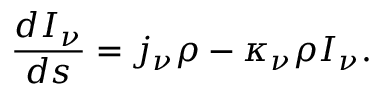Convert formula to latex. <formula><loc_0><loc_0><loc_500><loc_500>{ \frac { d I _ { \nu } } { d s } } = j _ { \nu } \rho - \kappa _ { \nu } \rho I _ { \nu } .</formula> 